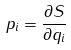Convert formula to latex. <formula><loc_0><loc_0><loc_500><loc_500>p _ { i } = \frac { \partial S } { \partial q _ { i } }</formula> 